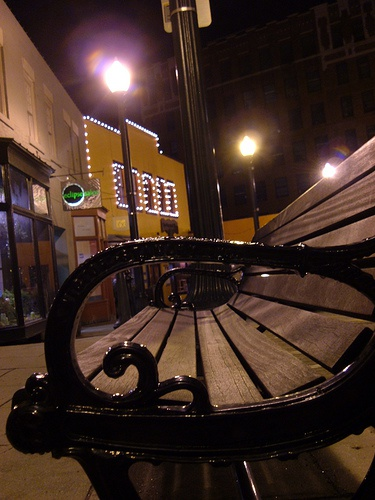Describe the objects in this image and their specific colors. I can see a bench in brown, black, gray, and maroon tones in this image. 